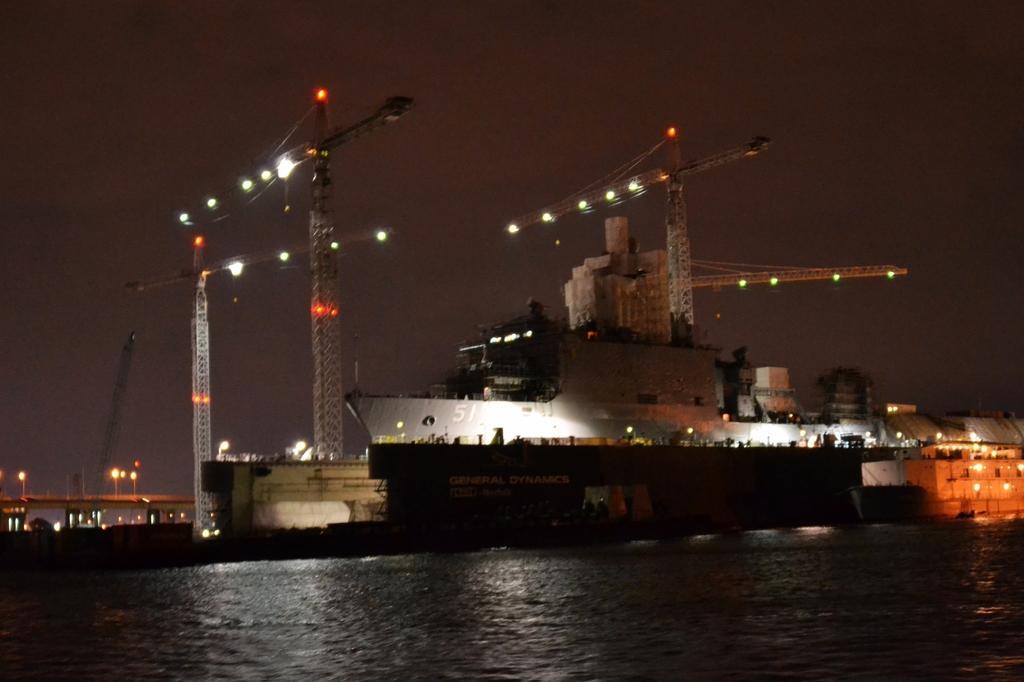How would you summarize this image in a sentence or two? In this image I can see few ships,water,lights and building. The image is dark. 